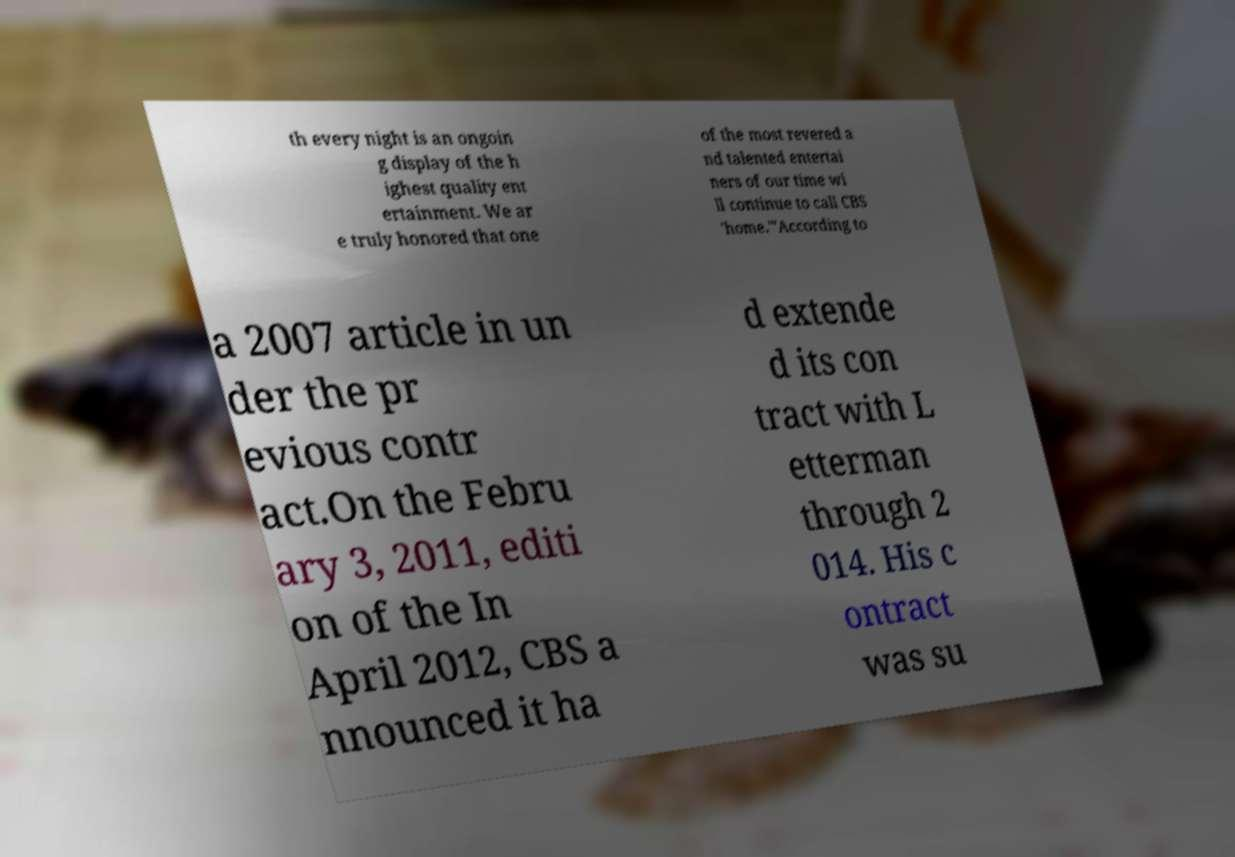Please identify and transcribe the text found in this image. th every night is an ongoin g display of the h ighest quality ent ertainment. We ar e truly honored that one of the most revered a nd talented entertai ners of our time wi ll continue to call CBS 'home.'"According to a 2007 article in un der the pr evious contr act.On the Febru ary 3, 2011, editi on of the In April 2012, CBS a nnounced it ha d extende d its con tract with L etterman through 2 014. His c ontract was su 